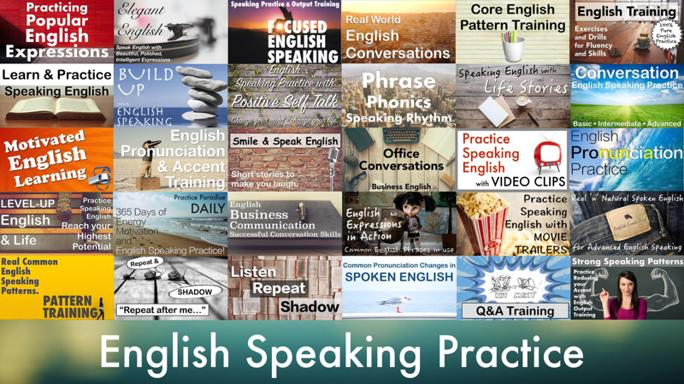What role do motivational strategies play in learning English according to the image? The image stresses the importance of motivational strategies such as 'Positive Self-talk' and '365 Days of English Practice', suggesting these play key roles in maintaining consistency and enthusiasm in language learning. Maintaining a positive mindset and routine are essential for overcoming challenges and making continuous progress. 